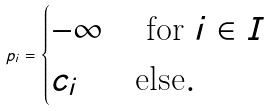Convert formula to latex. <formula><loc_0><loc_0><loc_500><loc_500>p _ { i } = \begin{cases} - \infty & \text { for } i \in I \\ c _ { i } & \text {else} . \end{cases}</formula> 